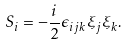<formula> <loc_0><loc_0><loc_500><loc_500>S _ { i } = - \frac { i } { 2 } \epsilon _ { i j k } \xi _ { j } \xi _ { k } .</formula> 